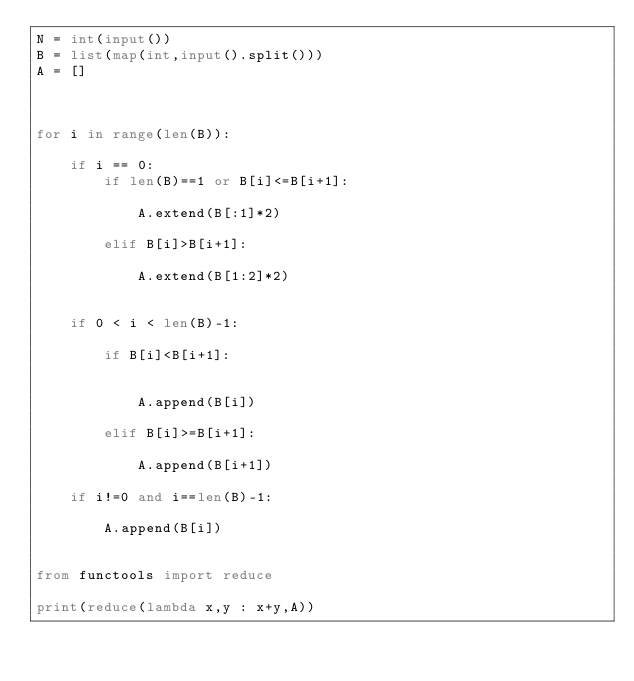Convert code to text. <code><loc_0><loc_0><loc_500><loc_500><_Python_>N = int(input())
B = list(map(int,input().split()))
A = []



for i in range(len(B)):

    if i == 0:
        if len(B)==1 or B[i]<=B[i+1]:

            A.extend(B[:1]*2)

        elif B[i]>B[i+1]:

            A.extend(B[1:2]*2)

            
    if 0 < i < len(B)-1:

        if B[i]<B[i+1]:


            A.append(B[i])

        elif B[i]>=B[i+1]:

            A.append(B[i+1])

    if i!=0 and i==len(B)-1:

        A.append(B[i])
            
        
from functools import reduce

print(reduce(lambda x,y : x+y,A))</code> 